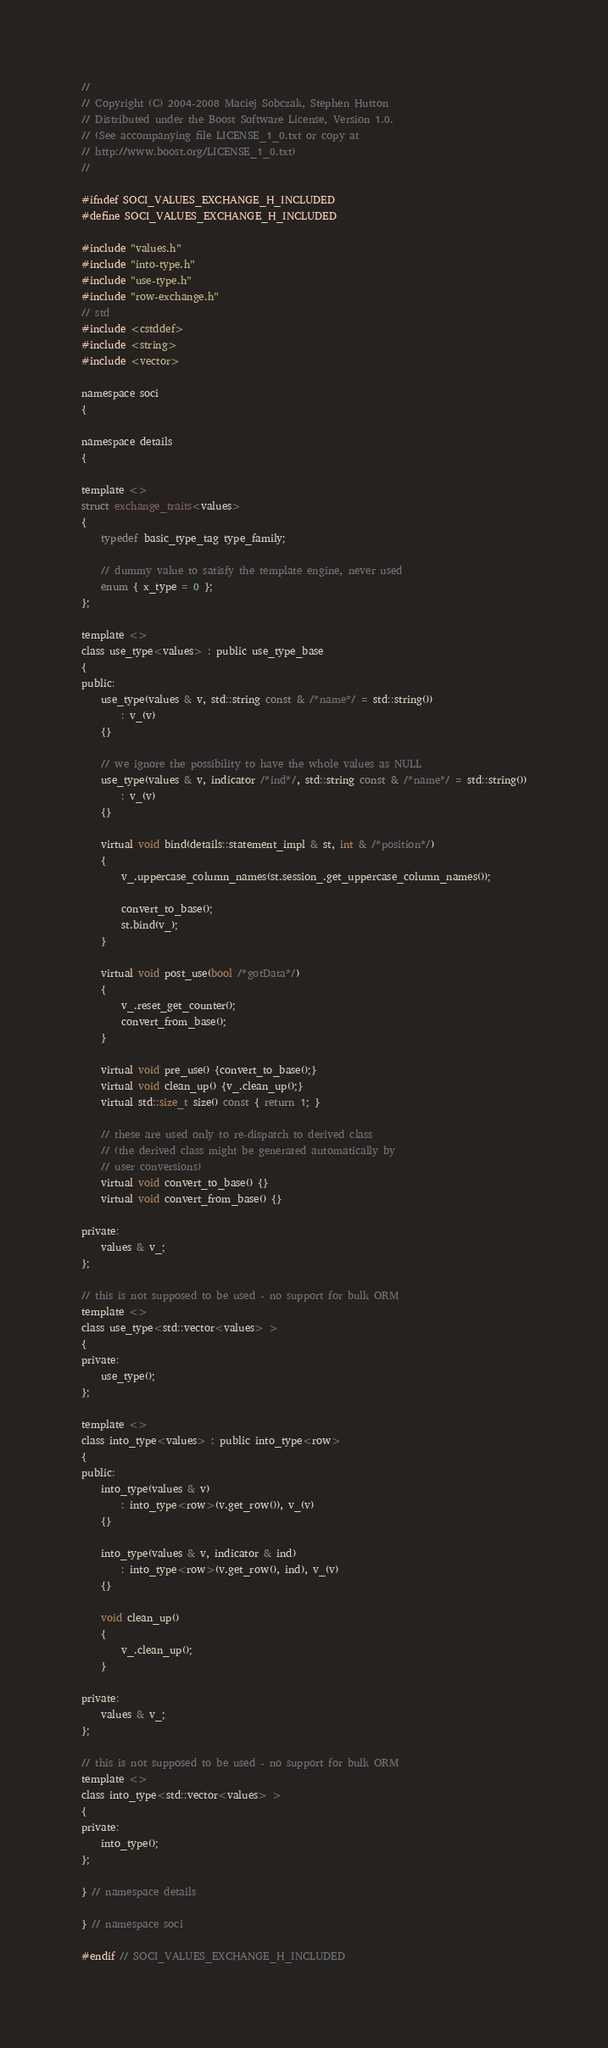<code> <loc_0><loc_0><loc_500><loc_500><_C_>//
// Copyright (C) 2004-2008 Maciej Sobczak, Stephen Hutton
// Distributed under the Boost Software License, Version 1.0.
// (See accompanying file LICENSE_1_0.txt or copy at
// http://www.boost.org/LICENSE_1_0.txt)
//

#ifndef SOCI_VALUES_EXCHANGE_H_INCLUDED
#define SOCI_VALUES_EXCHANGE_H_INCLUDED

#include "values.h"
#include "into-type.h"
#include "use-type.h"
#include "row-exchange.h"
// std
#include <cstddef>
#include <string>
#include <vector>

namespace soci
{

namespace details
{

template <>
struct exchange_traits<values>
{
    typedef basic_type_tag type_family;

    // dummy value to satisfy the template engine, never used
    enum { x_type = 0 };
};

template <>
class use_type<values> : public use_type_base
{
public:
    use_type(values & v, std::string const & /*name*/ = std::string())
        : v_(v)
    {}

    // we ignore the possibility to have the whole values as NULL
    use_type(values & v, indicator /*ind*/, std::string const & /*name*/ = std::string())
        : v_(v)
    {}

    virtual void bind(details::statement_impl & st, int & /*position*/)
    {
        v_.uppercase_column_names(st.session_.get_uppercase_column_names());

        convert_to_base();
        st.bind(v_);
    }

    virtual void post_use(bool /*gotData*/)
    {
        v_.reset_get_counter();
        convert_from_base();
    }

    virtual void pre_use() {convert_to_base();}
    virtual void clean_up() {v_.clean_up();}
    virtual std::size_t size() const { return 1; }

    // these are used only to re-dispatch to derived class
    // (the derived class might be generated automatically by
    // user conversions)
    virtual void convert_to_base() {}
    virtual void convert_from_base() {}

private:
    values & v_;
};

// this is not supposed to be used - no support for bulk ORM
template <>
class use_type<std::vector<values> >
{
private:
    use_type();
};

template <>
class into_type<values> : public into_type<row>
{
public:
    into_type(values & v)
        : into_type<row>(v.get_row()), v_(v)
    {}
    
    into_type(values & v, indicator & ind)
        : into_type<row>(v.get_row(), ind), v_(v)
    {}

    void clean_up()
    {
        v_.clean_up();
    }

private:
    values & v_;
};

// this is not supposed to be used - no support for bulk ORM
template <>
class into_type<std::vector<values> >
{
private:
    into_type();
};

} // namespace details

} // namespace soci

#endif // SOCI_VALUES_EXCHANGE_H_INCLUDED
</code> 